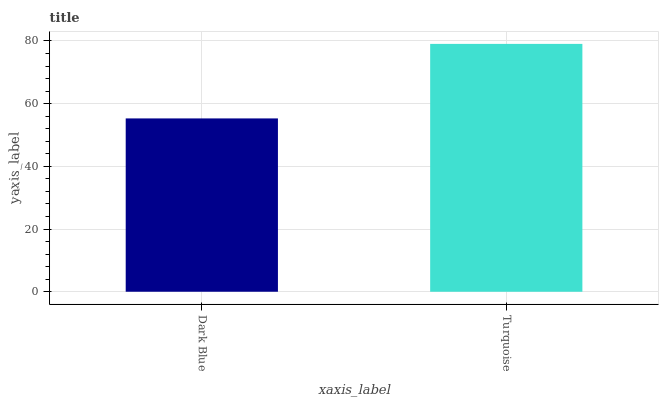Is Dark Blue the minimum?
Answer yes or no. Yes. Is Turquoise the maximum?
Answer yes or no. Yes. Is Turquoise the minimum?
Answer yes or no. No. Is Turquoise greater than Dark Blue?
Answer yes or no. Yes. Is Dark Blue less than Turquoise?
Answer yes or no. Yes. Is Dark Blue greater than Turquoise?
Answer yes or no. No. Is Turquoise less than Dark Blue?
Answer yes or no. No. Is Turquoise the high median?
Answer yes or no. Yes. Is Dark Blue the low median?
Answer yes or no. Yes. Is Dark Blue the high median?
Answer yes or no. No. Is Turquoise the low median?
Answer yes or no. No. 